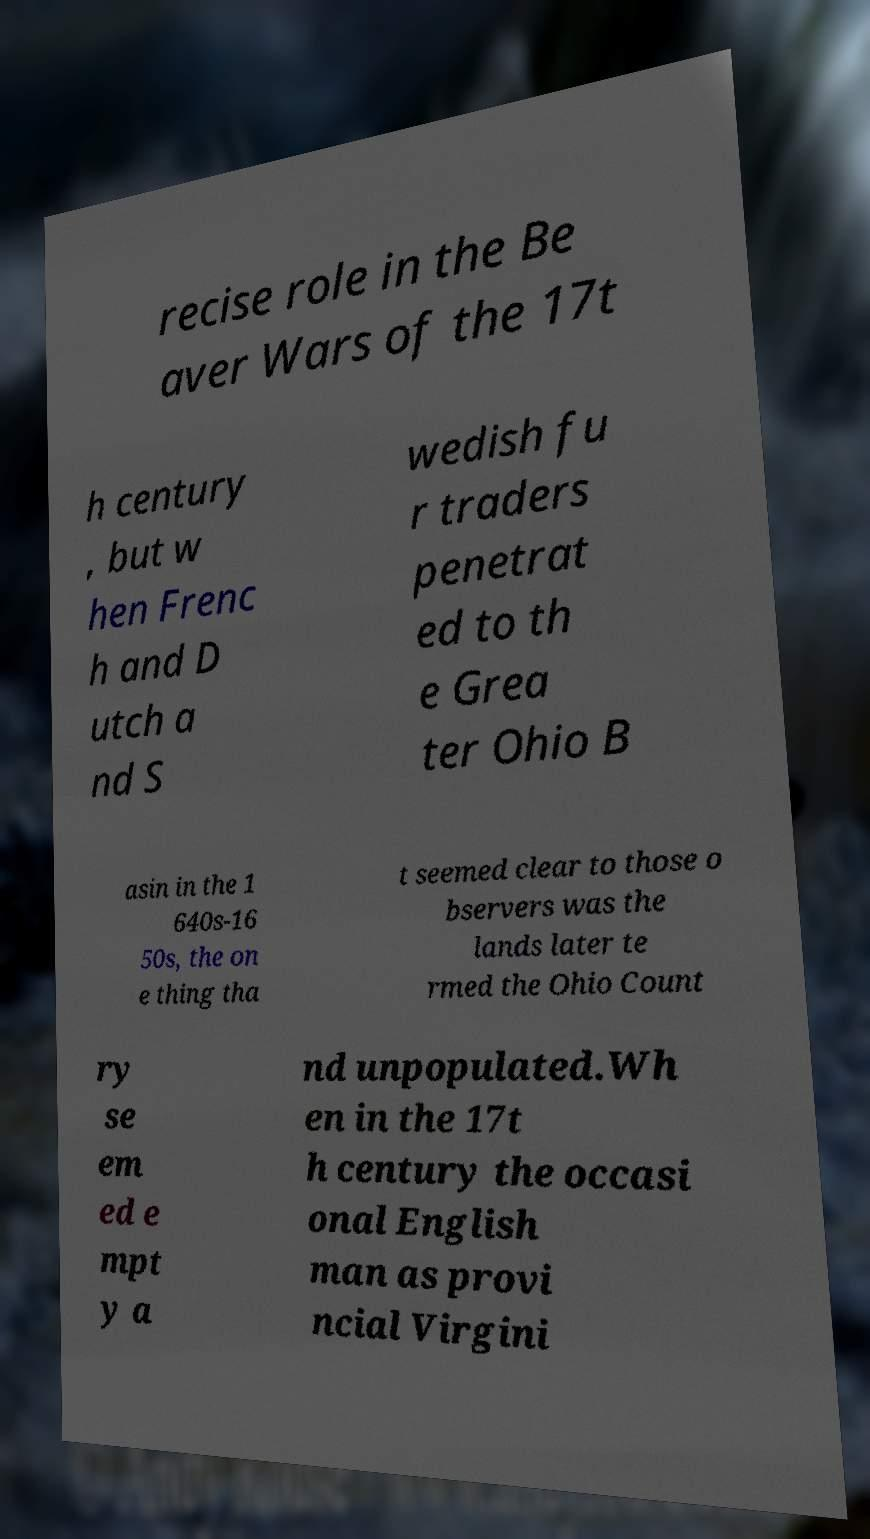Can you read and provide the text displayed in the image?This photo seems to have some interesting text. Can you extract and type it out for me? recise role in the Be aver Wars of the 17t h century , but w hen Frenc h and D utch a nd S wedish fu r traders penetrat ed to th e Grea ter Ohio B asin in the 1 640s-16 50s, the on e thing tha t seemed clear to those o bservers was the lands later te rmed the Ohio Count ry se em ed e mpt y a nd unpopulated.Wh en in the 17t h century the occasi onal English man as provi ncial Virgini 